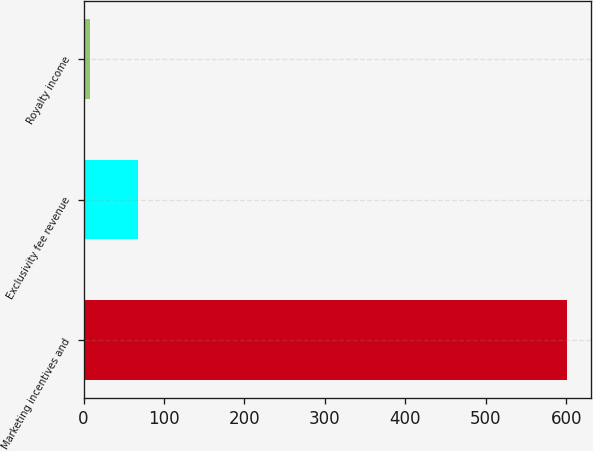Convert chart to OTSL. <chart><loc_0><loc_0><loc_500><loc_500><bar_chart><fcel>Marketing incentives and<fcel>Exclusivity fee revenue<fcel>Royalty income<nl><fcel>601<fcel>67.3<fcel>8<nl></chart> 